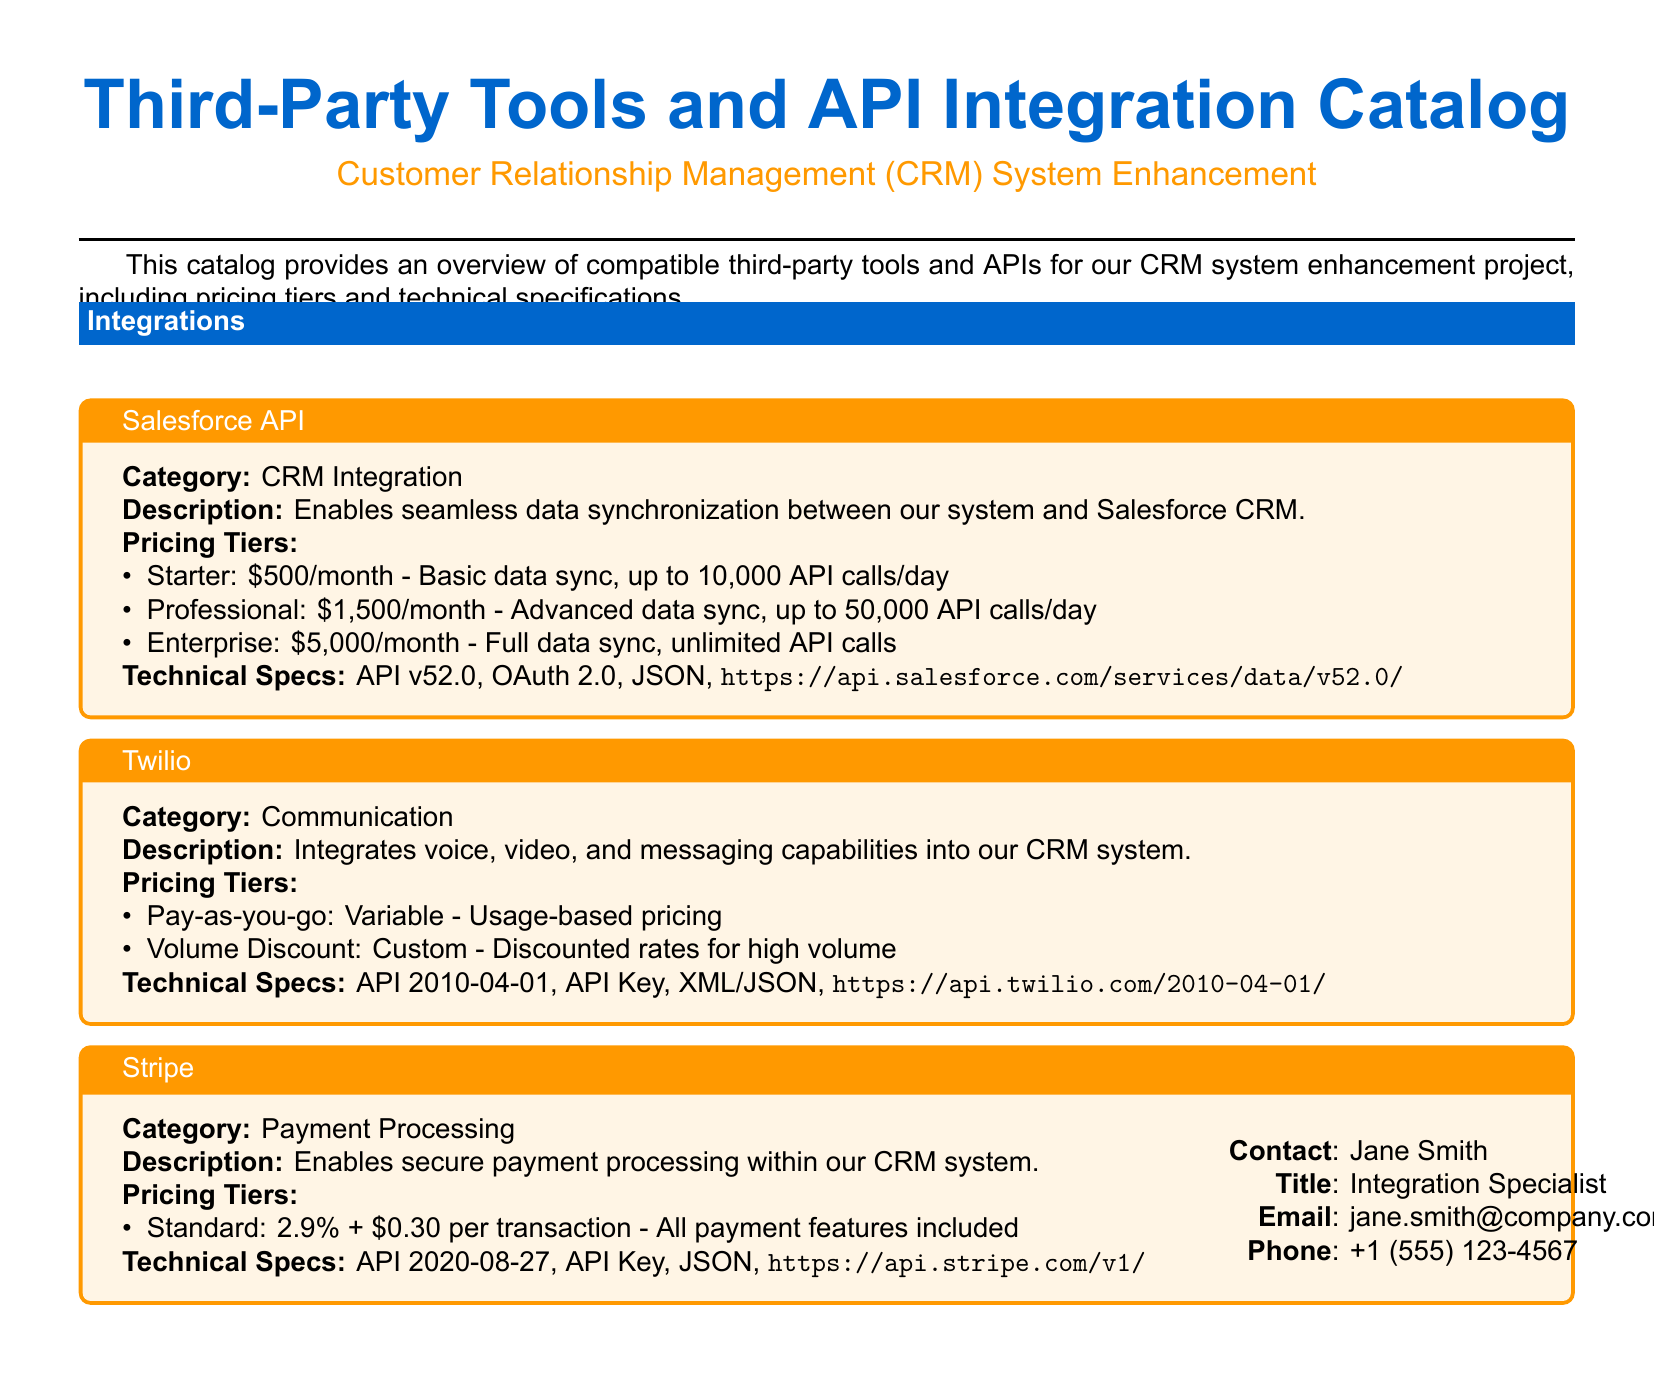What is the pricing for the Starter tier of Salesforce API? The Starter tier pricing is explicitly mentioned in the document as $500/month.
Answer: $500/month What category does Twilio fall under? The document categorizes Twilio as a Communication tool.
Answer: Communication What is the maximum number of API calls per day for the Enterprise tier of Salesforce API? The document states that the Enterprise tier allows unlimited API calls.
Answer: Unlimited What is the technical specification version for Stripe API? The document lists Stripe API technical specs as API 2020-08-27.
Answer: 2020-08-27 What is the cost structure of the Stripe payment processing? The document specifies that Stripe charges 2.9% + $0.30 per transaction.
Answer: 2.9% + $0.30 per transaction What type of pricing does Twilio offer for high volume usage? The document mentions that Twilio offers a custom volume discount for high usage rates.
Answer: Custom What is the contact email for the Integration Specialist? The document provides the email as jane.smith@company.com.
Answer: jane.smith@company.com How many API calls can the Professional tier of Salesforce API handle? According to the document, the Professional tier can handle up to 50,000 API calls/day.
Answer: 50,000 API calls/day 